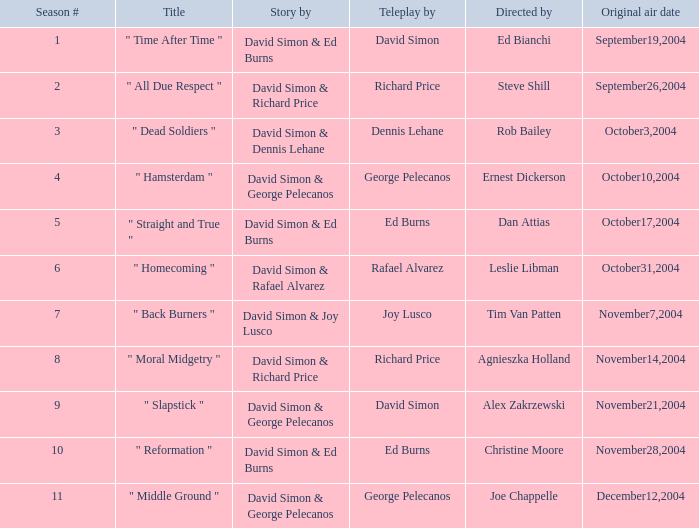Who is the teleplay by when the director is Rob Bailey? Dennis Lehane. 